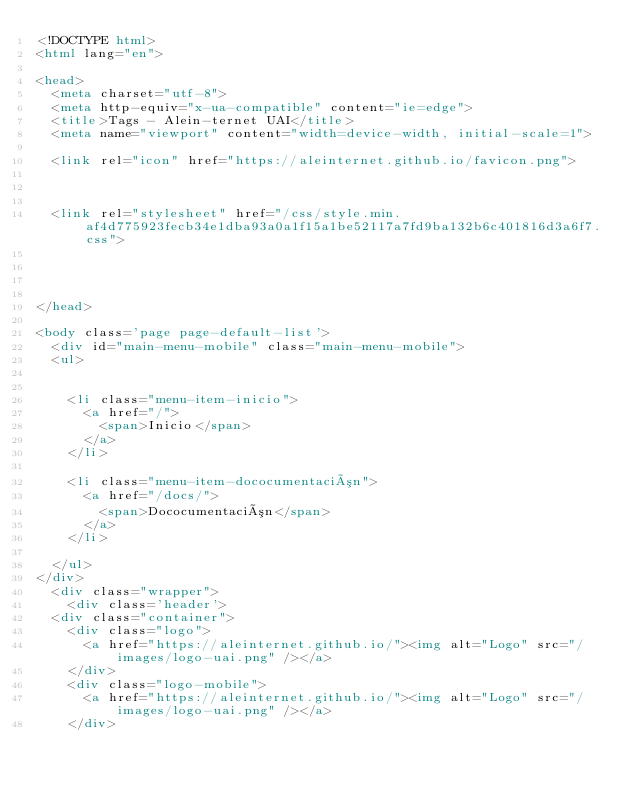<code> <loc_0><loc_0><loc_500><loc_500><_HTML_><!DOCTYPE html>
<html lang="en">

<head>
  <meta charset="utf-8">
  <meta http-equiv="x-ua-compatible" content="ie=edge">
  <title>Tags - Alein-ternet UAI</title>
  <meta name="viewport" content="width=device-width, initial-scale=1">
  
  <link rel="icon" href="https://aleinternet.github.io/favicon.png">

  
  
  <link rel="stylesheet" href="/css/style.min.af4d775923fecb34e1dba93a0a1f15a1be52117a7fd9ba132b6c401816d3a6f7.css">
  

  

</head>

<body class='page page-default-list'>
  <div id="main-menu-mobile" class="main-menu-mobile">
  <ul>
    
    
    <li class="menu-item-inicio">
      <a href="/">
        <span>Inicio</span>
      </a>
    </li>
    
    <li class="menu-item-dococumentación">
      <a href="/docs/">
        <span>Dococumentación</span>
      </a>
    </li>
    
  </ul>
</div>
  <div class="wrapper">
    <div class='header'>
  <div class="container">
    <div class="logo">
      <a href="https://aleinternet.github.io/"><img alt="Logo" src="/images/logo-uai.png" /></a>
    </div>
    <div class="logo-mobile">
      <a href="https://aleinternet.github.io/"><img alt="Logo" src="/images/logo-uai.png" /></a>
    </div></code> 